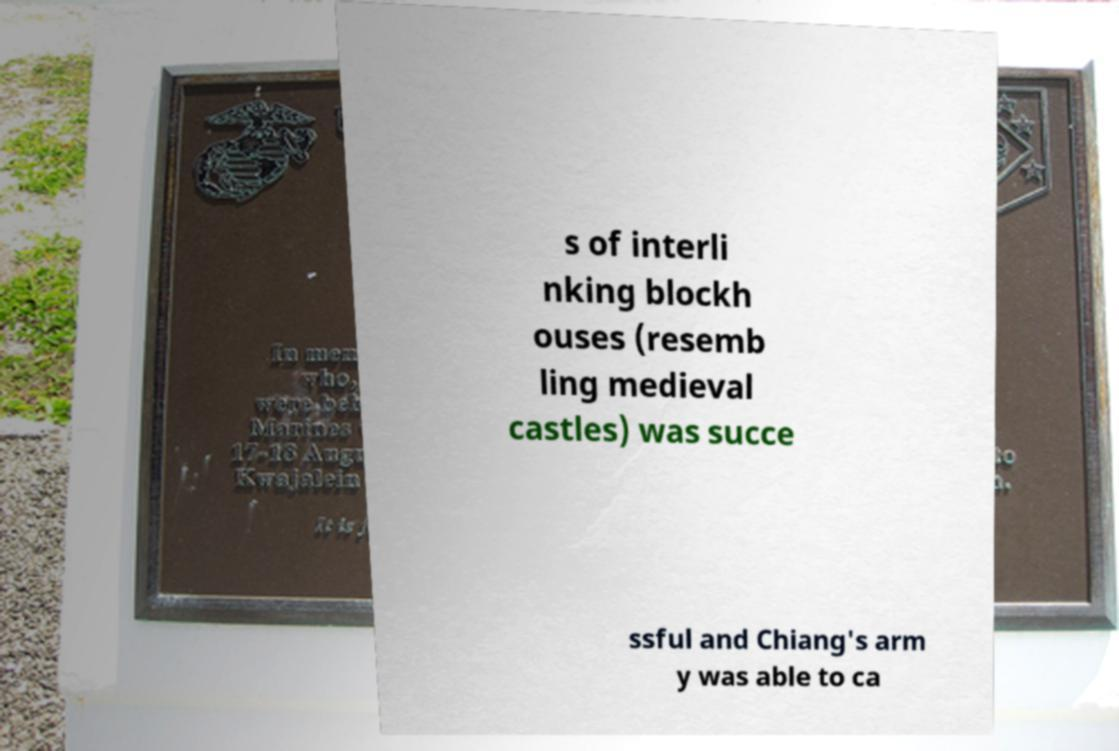For documentation purposes, I need the text within this image transcribed. Could you provide that? s of interli nking blockh ouses (resemb ling medieval castles) was succe ssful and Chiang's arm y was able to ca 